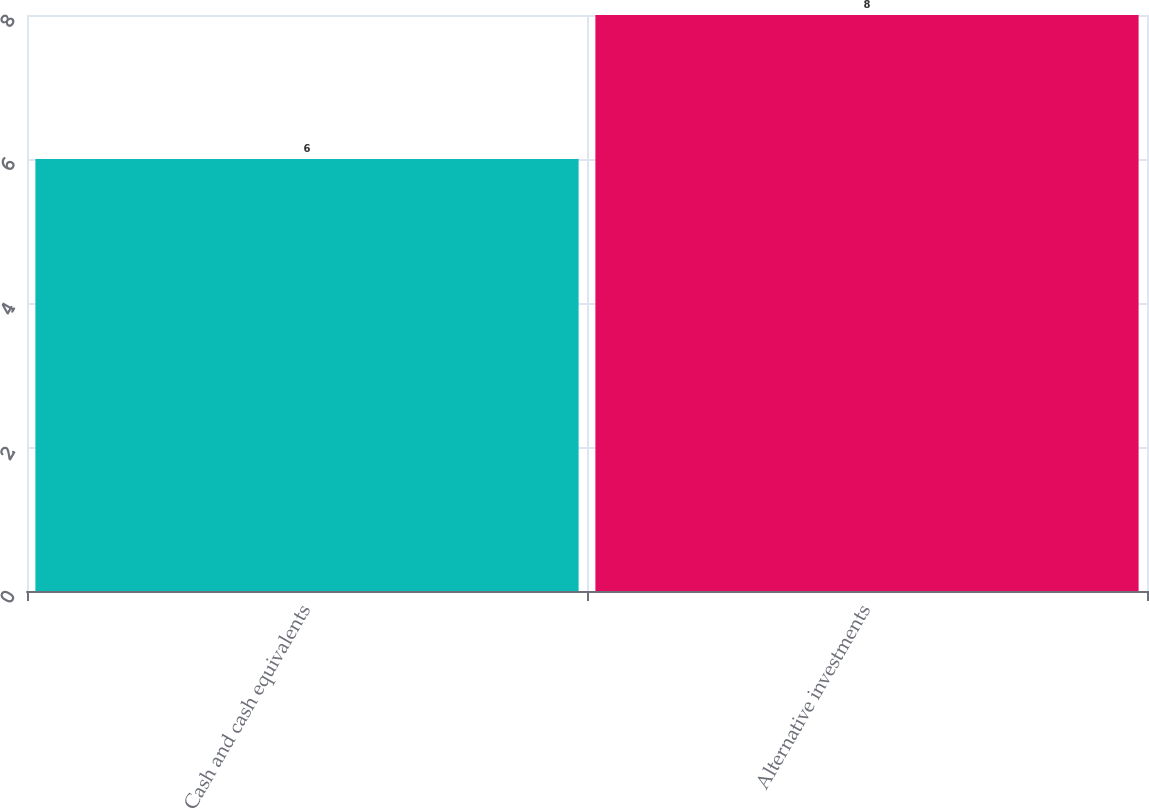Convert chart. <chart><loc_0><loc_0><loc_500><loc_500><bar_chart><fcel>Cash and cash equivalents<fcel>Alternative investments<nl><fcel>6<fcel>8<nl></chart> 